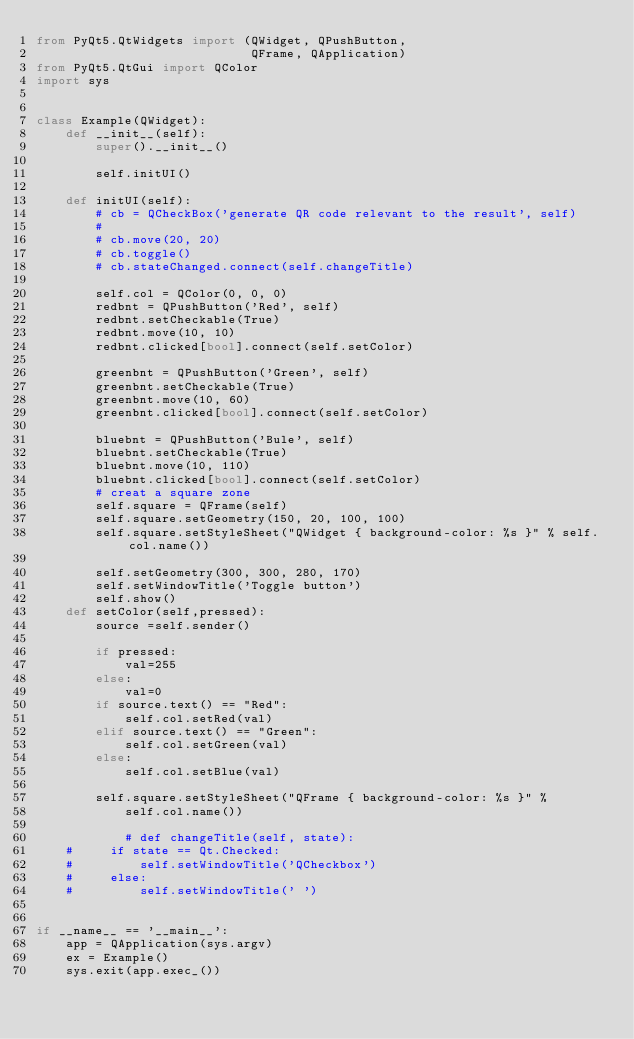Convert code to text. <code><loc_0><loc_0><loc_500><loc_500><_Python_>from PyQt5.QtWidgets import (QWidget, QPushButton,
                             QFrame, QApplication)
from PyQt5.QtGui import QColor
import sys


class Example(QWidget):
    def __init__(self):
        super().__init__()

        self.initUI()

    def initUI(self):
        # cb = QCheckBox('generate QR code relevant to the result', self)
        #
        # cb.move(20, 20)
        # cb.toggle()
        # cb.stateChanged.connect(self.changeTitle)

        self.col = QColor(0, 0, 0)
        redbnt = QPushButton('Red', self)
        redbnt.setCheckable(True)
        redbnt.move(10, 10)
        redbnt.clicked[bool].connect(self.setColor)

        greenbnt = QPushButton('Green', self)
        greenbnt.setCheckable(True)
        greenbnt.move(10, 60)
        greenbnt.clicked[bool].connect(self.setColor)

        bluebnt = QPushButton('Bule', self)
        bluebnt.setCheckable(True)
        bluebnt.move(10, 110)
        bluebnt.clicked[bool].connect(self.setColor)
        # creat a square zone
        self.square = QFrame(self)
        self.square.setGeometry(150, 20, 100, 100)
        self.square.setStyleSheet("QWidget { background-color: %s }" % self.col.name())

        self.setGeometry(300, 300, 280, 170)
        self.setWindowTitle('Toggle button')
        self.show()
    def setColor(self,pressed):
        source =self.sender()

        if pressed:
            val=255
        else:
            val=0
        if source.text() == "Red":
            self.col.setRed(val)
        elif source.text() == "Green":
            self.col.setGreen(val)
        else:
            self.col.setBlue(val)

        self.square.setStyleSheet("QFrame { background-color: %s }" %
            self.col.name())

            # def changeTitle(self, state):
    #     if state == Qt.Checked:
    #         self.setWindowTitle('QCheckbox')
    #     else:
    #         self.setWindowTitle(' ')


if __name__ == '__main__':
    app = QApplication(sys.argv)
    ex = Example()
    sys.exit(app.exec_())
</code> 